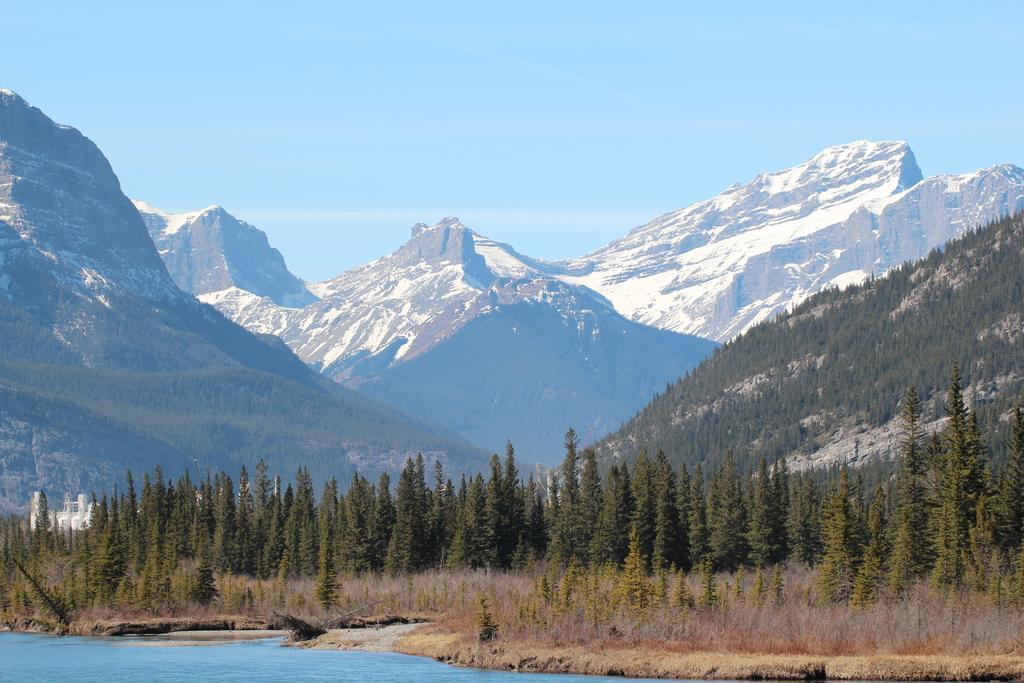In one or two sentences, can you explain what this image depicts? In this image we can see a group of trees, some plants, water, some buildings, the ice hills and the sky. 